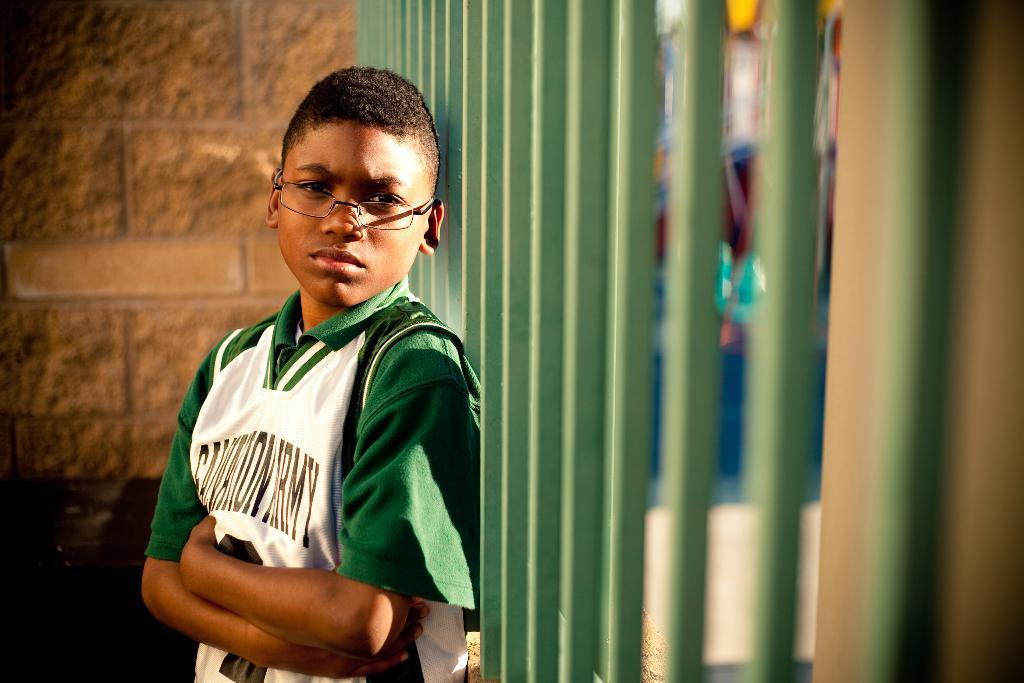Can you describe this image briefly? In this image we can see a boy wearing specs. In the back there is a wall. Near to him there is a railing with poles. In the background it is blur. 